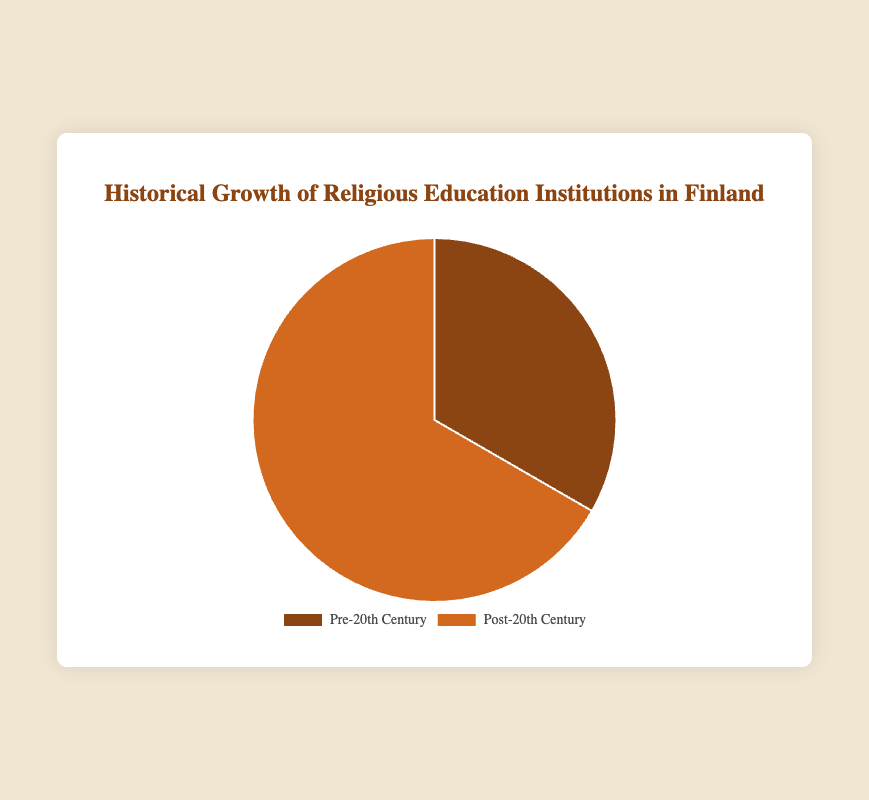Which period has the most religious education institutions? The post-20th century period has more religious education institutions. This is shown on the pie chart where the 'Post-20th Century' section is larger than the 'Pre-20th Century' section.
Answer: Post-20th Century How many institutions were founded in the Pre-20th Century? The pie chart shows the segment labeled 'Pre-20th Century' which represents 2 institutions.
Answer: 2 Compare the number of institutions in the Pre-20th Century to those in the Post-20th Century. The Pre-20th Century has 2 institutions, while the Post-20th Century has 4 institutions. 4 is greater than 2.
Answer: The Post-20th Century has more What fraction of the total institutions were established in the Pre-20th Century? There are a total of 6 institutions (2 from Pre-20th Century and 4 from Post-20th Century). The fraction for Pre-20th Century is 2 out of 6 which simplifies to 1/3.
Answer: 1/3 What percentage of the total institutions were founded post-20th Century? There are 4 institutions in the Post-20th Century and 6 institutions in total. The percentage is calculated as (4 / 6) * 100 = 66.67%.
Answer: 66.67% Which periods' institutions are represented by the darker color on the pie chart? The pie chart uses darker and lighter brown shades to distinguish between periods. The explanation in the HTML code hints that the first section (likely 'Pre-20th Century') is the darker color.
Answer: Pre-20th Century If an institution were randomly chosen, what is the probability that it was founded after the 20th Century? There are 4 institutions founded post-20th Century out of a total of 6 institutions. The probability is calculated as 4/6 = 2/3.
Answer: 2/3 How many more institutions are there in the Post-20th Century compared to the Pre-20th Century? The Post-20th Century period has 4 institutions, and the Pre-20th Century has 2 institutions. The difference is 4 - 2 = 2.
Answer: 2 Which period's institutions are represented by the larger segment in the pie chart? Observing the pie chart, the 'Post-20th Century' segment is larger. This indicates there are more institutions founded in this period.
Answer: Post-20th Century 